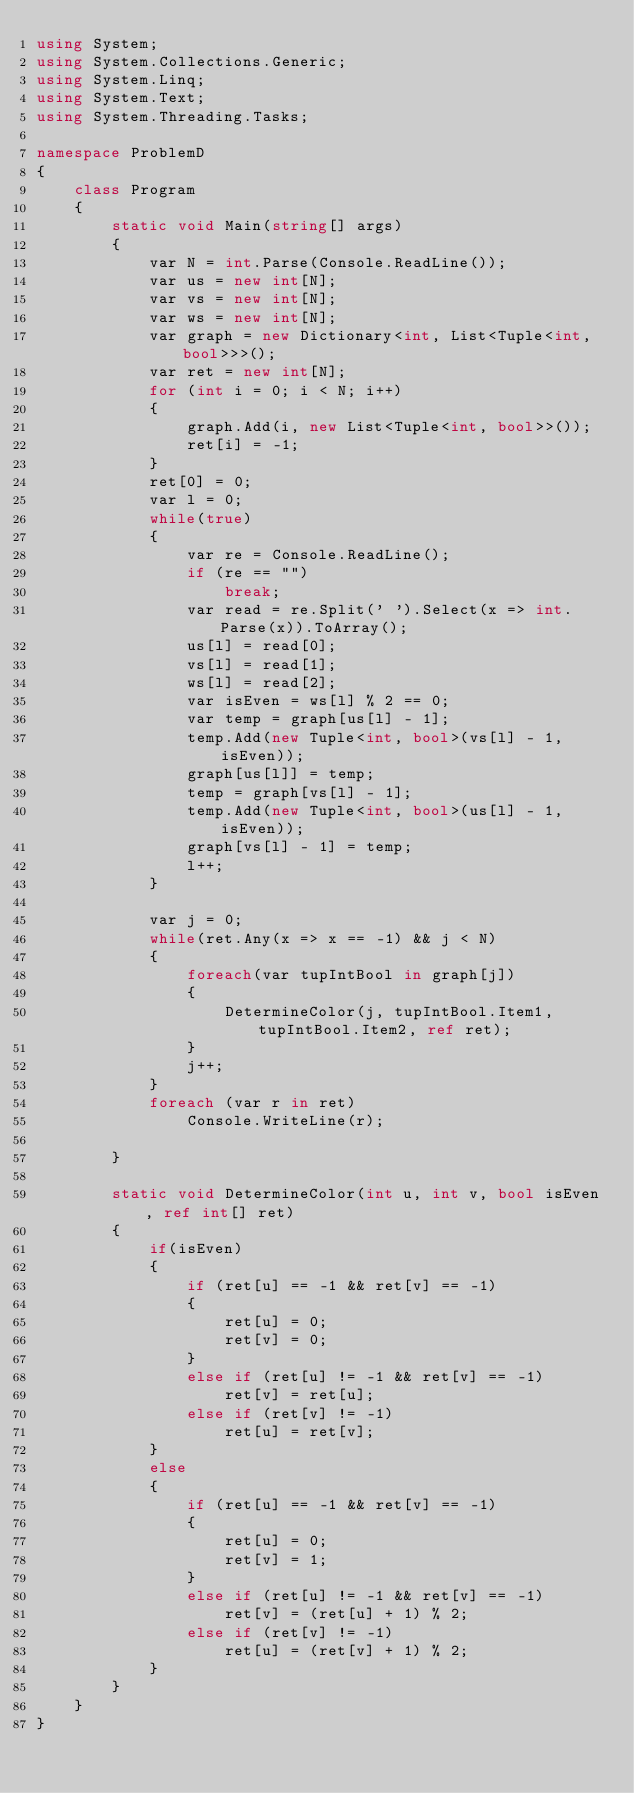<code> <loc_0><loc_0><loc_500><loc_500><_C#_>using System;
using System.Collections.Generic;
using System.Linq;
using System.Text;
using System.Threading.Tasks;

namespace ProblemD
{
    class Program
    {
        static void Main(string[] args)
        {
            var N = int.Parse(Console.ReadLine());
            var us = new int[N];
            var vs = new int[N];
            var ws = new int[N];
            var graph = new Dictionary<int, List<Tuple<int, bool>>>();
            var ret = new int[N];
            for (int i = 0; i < N; i++)
            {
                graph.Add(i, new List<Tuple<int, bool>>());
                ret[i] = -1;
            }
            ret[0] = 0;
            var l = 0;
            while(true)
            {
                var re = Console.ReadLine();
                if (re == "")
                    break;
                var read = re.Split(' ').Select(x => int.Parse(x)).ToArray();
                us[l] = read[0];
                vs[l] = read[1];
                ws[l] = read[2];
                var isEven = ws[l] % 2 == 0;
                var temp = graph[us[l] - 1];
                temp.Add(new Tuple<int, bool>(vs[l] - 1, isEven));
                graph[us[l]] = temp;
                temp = graph[vs[l] - 1];
                temp.Add(new Tuple<int, bool>(us[l] - 1, isEven));
                graph[vs[l] - 1] = temp;
                l++;
            }

            var j = 0;
            while(ret.Any(x => x == -1) && j < N)
            {
                foreach(var tupIntBool in graph[j])
                {
                    DetermineColor(j, tupIntBool.Item1, tupIntBool.Item2, ref ret);
                }
                j++;
            }
            foreach (var r in ret)
                Console.WriteLine(r);

        }

        static void DetermineColor(int u, int v, bool isEven, ref int[] ret)
        {
            if(isEven)
            {
                if (ret[u] == -1 && ret[v] == -1)
                {
                    ret[u] = 0;
                    ret[v] = 0;
                }
                else if (ret[u] != -1 && ret[v] == -1)
                    ret[v] = ret[u];
                else if (ret[v] != -1)
                    ret[u] = ret[v];
            }
            else
            {
                if (ret[u] == -1 && ret[v] == -1)
                {
                    ret[u] = 0;
                    ret[v] = 1;
                }
                else if (ret[u] != -1 && ret[v] == -1)
                    ret[v] = (ret[u] + 1) % 2;
                else if (ret[v] != -1)
                    ret[u] = (ret[v] + 1) % 2;
            }
        }
    }
}
</code> 